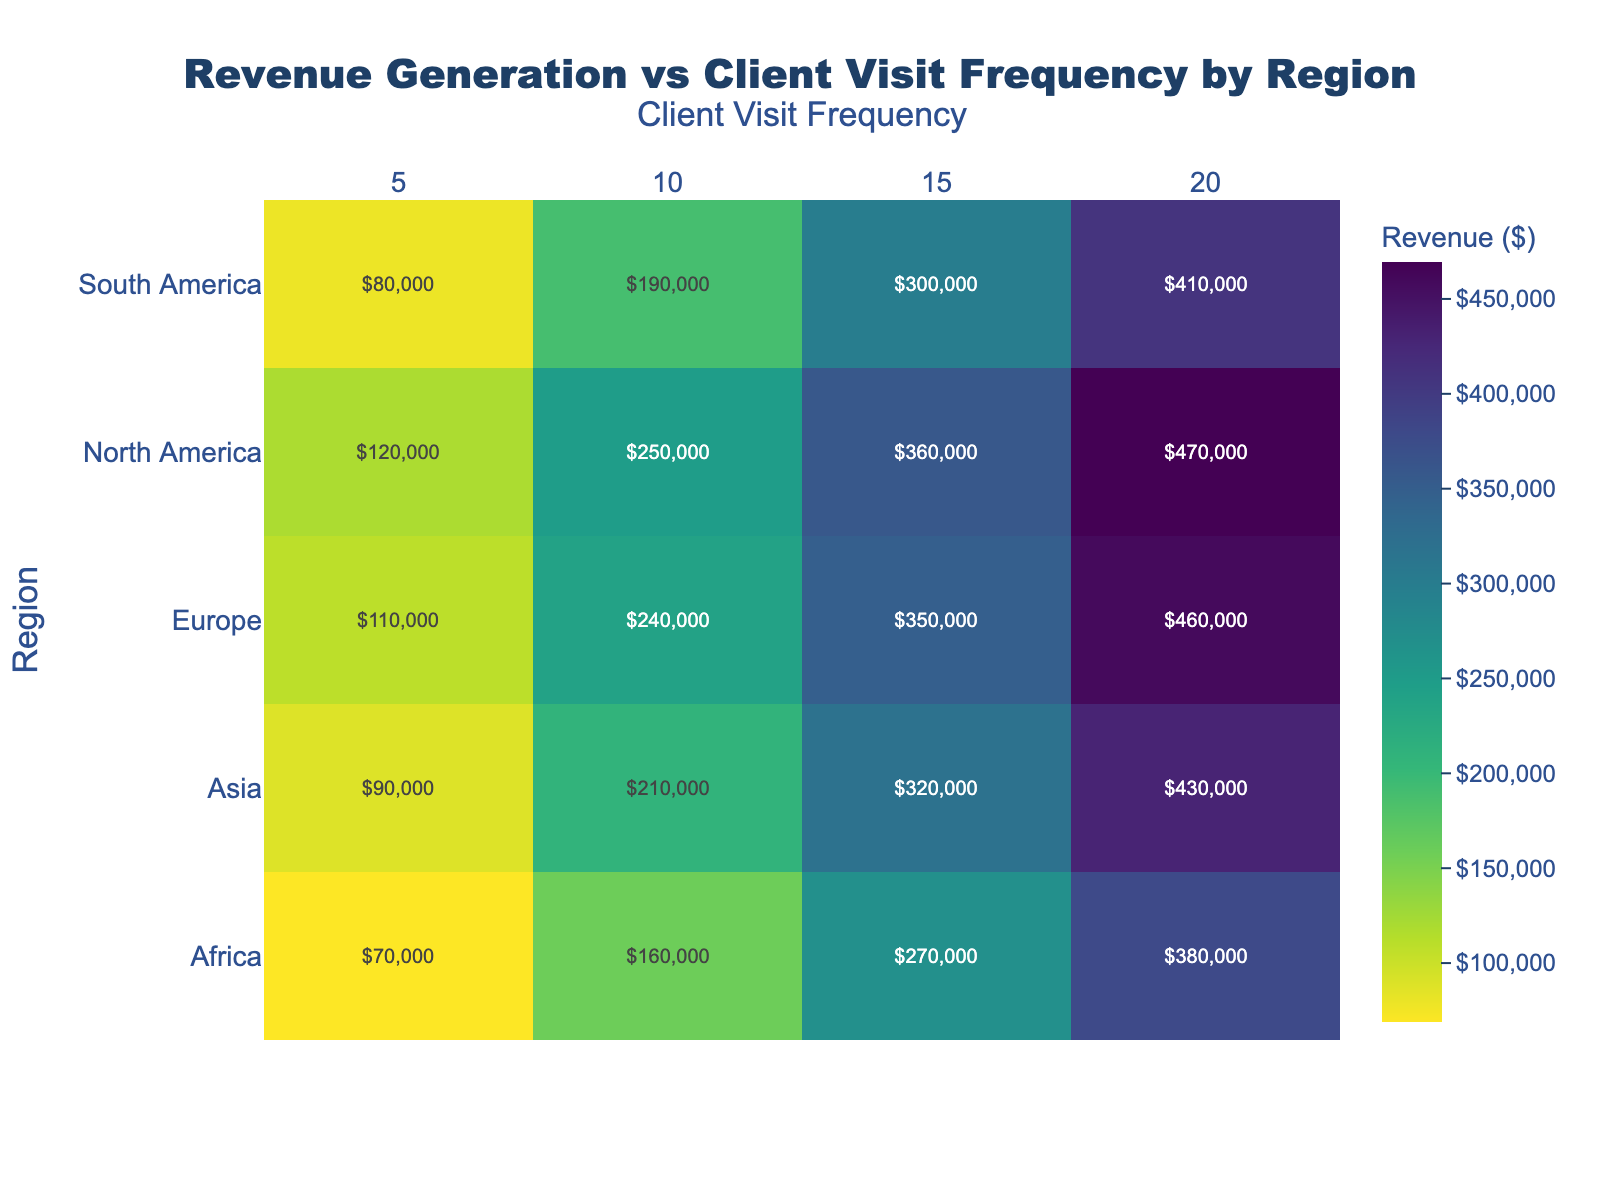What is the title of the heatmap? The title is located at the top of the heatmap and is usually very prominent.
Answer: Revenue Generation vs Client Visit Frequency by Region Which region generates the highest revenue with 20 client visits? By looking at the intersection of the "Region" column for highest revenue and the "Client Visit Frequency" column with 20, we check for the highest value.
Answer: North America How does the revenue in Europe with 10 client visits compare to that in Asia with 10 client visits? Locate the 10 client visits column for both Europe and Asia and compare the values; Europe has 240,000 while Asia has 210,000.
Answer: Europe's revenue is higher What is the range of revenue for North America? Locate the values for North America across all client visit frequencies and subtract the smallest value from the largest value; 470,000 - 120,000.
Answer: 350,000 What is the average revenue generation for 15 client visits across all regions? Sum the revenue values for 15 client visits across all regions and divide by the number of regions; (360,000 + 350,000 + 320,000 + 300,000 + 270,000) / 5 = 320,000.
Answer: 320,000 Which region has the lowest revenue when the client visit frequency is 5? Locate the 5 client visits column and identify the smallest value among all regions listed under this column.
Answer: Africa What is the difference in revenue between North America and South America with 20 client visits? Subtract the revenue value for South America from the revenue value for North America with 20 client visits; 470,000 - 410,000.
Answer: 60,000 What is the median revenue for Africa across all client visit frequencies? Sort the revenue values for Africa (70,000, 160,000, 270,000, 380,000) and find the middle value(s); the average of the two middle values is ((160,000 + 270,000) / 2).
Answer: 215,000 Is there any region where all revenue values fall below 400,000? Check the maximum revenue value for each region to see if any is below 400,000; Only Africa has all values below 400,000.
Answer: Yes, Africa Which client visit frequency generally results in the highest revenue across regions? Identify the client visit frequency with the highest average revenue by calculating the sum of revenues for each frequency and comparing; 20 client visits have the high values in multiple regions.
Answer: 20 